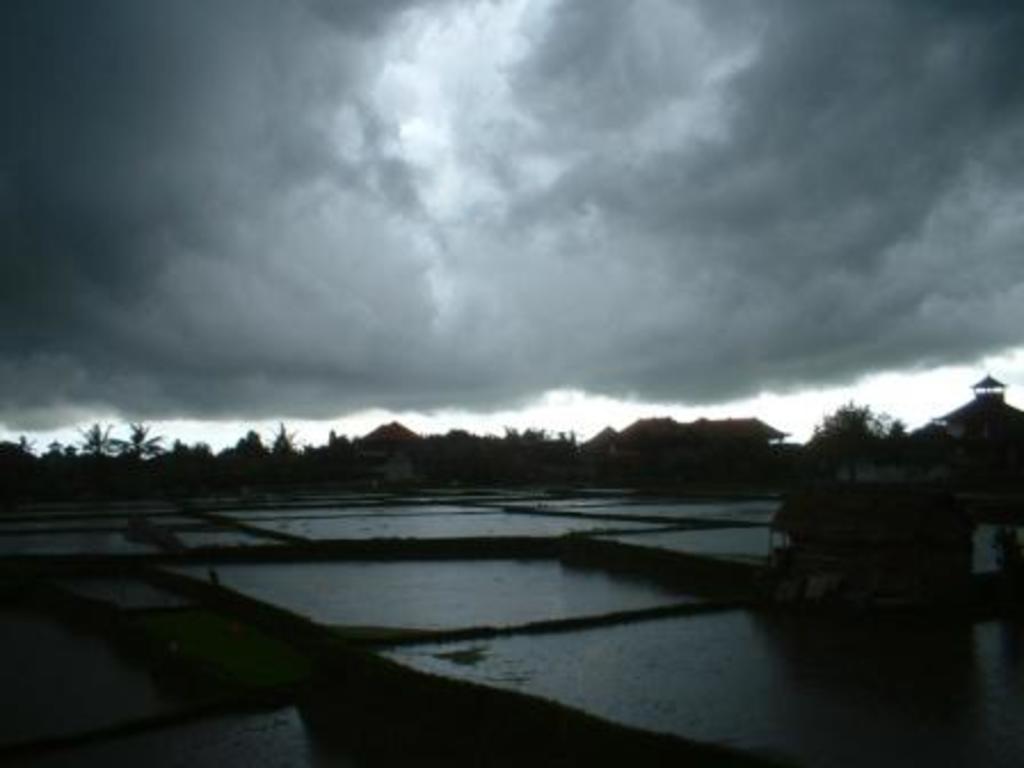Can you describe this image briefly? In this image in the front there is water and there is an object which is visible. In the background there are trees, houses and the sky is cloudy. 